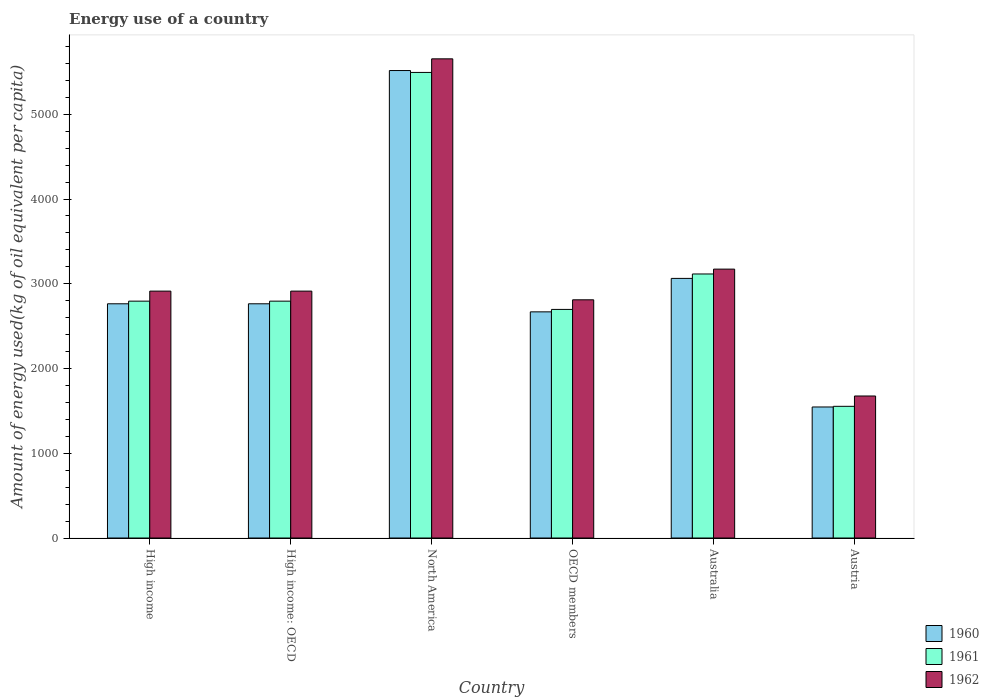How many groups of bars are there?
Your answer should be very brief. 6. Are the number of bars on each tick of the X-axis equal?
Your answer should be very brief. Yes. How many bars are there on the 2nd tick from the left?
Your response must be concise. 3. How many bars are there on the 5th tick from the right?
Keep it short and to the point. 3. In how many cases, is the number of bars for a given country not equal to the number of legend labels?
Offer a very short reply. 0. What is the amount of energy used in in 1960 in High income: OECD?
Your answer should be very brief. 2763.96. Across all countries, what is the maximum amount of energy used in in 1962?
Make the answer very short. 5654.54. Across all countries, what is the minimum amount of energy used in in 1961?
Ensure brevity in your answer.  1554.03. What is the total amount of energy used in in 1961 in the graph?
Provide a succinct answer. 1.85e+04. What is the difference between the amount of energy used in in 1962 in Australia and that in High income: OECD?
Keep it short and to the point. 259.55. What is the difference between the amount of energy used in in 1961 in Austria and the amount of energy used in in 1960 in Australia?
Offer a terse response. -1509.52. What is the average amount of energy used in in 1961 per country?
Offer a very short reply. 3075.28. What is the difference between the amount of energy used in of/in 1962 and amount of energy used in of/in 1960 in High income: OECD?
Give a very brief answer. 149.47. What is the ratio of the amount of energy used in in 1961 in Austria to that in High income?
Keep it short and to the point. 0.56. Is the difference between the amount of energy used in in 1962 in Australia and Austria greater than the difference between the amount of energy used in in 1960 in Australia and Austria?
Make the answer very short. No. What is the difference between the highest and the second highest amount of energy used in in 1961?
Your answer should be compact. -2378.3. What is the difference between the highest and the lowest amount of energy used in in 1962?
Provide a succinct answer. 3978.67. In how many countries, is the amount of energy used in in 1962 greater than the average amount of energy used in in 1962 taken over all countries?
Give a very brief answer. 1. Is the sum of the amount of energy used in in 1961 in Austria and High income: OECD greater than the maximum amount of energy used in in 1960 across all countries?
Your answer should be very brief. No. What does the 1st bar from the left in North America represents?
Your answer should be very brief. 1960. Is it the case that in every country, the sum of the amount of energy used in in 1962 and amount of energy used in in 1961 is greater than the amount of energy used in in 1960?
Keep it short and to the point. Yes. How many bars are there?
Ensure brevity in your answer.  18. How many countries are there in the graph?
Offer a terse response. 6. What is the difference between two consecutive major ticks on the Y-axis?
Offer a terse response. 1000. Are the values on the major ticks of Y-axis written in scientific E-notation?
Offer a terse response. No. How are the legend labels stacked?
Provide a short and direct response. Vertical. What is the title of the graph?
Your answer should be very brief. Energy use of a country. What is the label or title of the Y-axis?
Offer a terse response. Amount of energy used(kg of oil equivalent per capita). What is the Amount of energy used(kg of oil equivalent per capita) in 1960 in High income?
Your response must be concise. 2763.96. What is the Amount of energy used(kg of oil equivalent per capita) of 1961 in High income?
Give a very brief answer. 2795.14. What is the Amount of energy used(kg of oil equivalent per capita) in 1962 in High income?
Ensure brevity in your answer.  2913.43. What is the Amount of energy used(kg of oil equivalent per capita) of 1960 in High income: OECD?
Your answer should be compact. 2763.96. What is the Amount of energy used(kg of oil equivalent per capita) of 1961 in High income: OECD?
Ensure brevity in your answer.  2795.14. What is the Amount of energy used(kg of oil equivalent per capita) of 1962 in High income: OECD?
Your answer should be very brief. 2913.43. What is the Amount of energy used(kg of oil equivalent per capita) in 1960 in North America?
Your answer should be very brief. 5516.36. What is the Amount of energy used(kg of oil equivalent per capita) in 1961 in North America?
Provide a short and direct response. 5494.09. What is the Amount of energy used(kg of oil equivalent per capita) of 1962 in North America?
Make the answer very short. 5654.54. What is the Amount of energy used(kg of oil equivalent per capita) in 1960 in OECD members?
Give a very brief answer. 2668.69. What is the Amount of energy used(kg of oil equivalent per capita) of 1961 in OECD members?
Your response must be concise. 2697.51. What is the Amount of energy used(kg of oil equivalent per capita) in 1962 in OECD members?
Your answer should be very brief. 2810.85. What is the Amount of energy used(kg of oil equivalent per capita) in 1960 in Australia?
Offer a very short reply. 3063.55. What is the Amount of energy used(kg of oil equivalent per capita) of 1961 in Australia?
Offer a terse response. 3115.79. What is the Amount of energy used(kg of oil equivalent per capita) of 1962 in Australia?
Make the answer very short. 3172.97. What is the Amount of energy used(kg of oil equivalent per capita) of 1960 in Austria?
Provide a short and direct response. 1546.26. What is the Amount of energy used(kg of oil equivalent per capita) in 1961 in Austria?
Provide a short and direct response. 1554.03. What is the Amount of energy used(kg of oil equivalent per capita) of 1962 in Austria?
Offer a very short reply. 1675.87. Across all countries, what is the maximum Amount of energy used(kg of oil equivalent per capita) of 1960?
Offer a terse response. 5516.36. Across all countries, what is the maximum Amount of energy used(kg of oil equivalent per capita) in 1961?
Offer a very short reply. 5494.09. Across all countries, what is the maximum Amount of energy used(kg of oil equivalent per capita) of 1962?
Provide a succinct answer. 5654.54. Across all countries, what is the minimum Amount of energy used(kg of oil equivalent per capita) in 1960?
Ensure brevity in your answer.  1546.26. Across all countries, what is the minimum Amount of energy used(kg of oil equivalent per capita) in 1961?
Offer a terse response. 1554.03. Across all countries, what is the minimum Amount of energy used(kg of oil equivalent per capita) of 1962?
Your answer should be compact. 1675.87. What is the total Amount of energy used(kg of oil equivalent per capita) in 1960 in the graph?
Offer a very short reply. 1.83e+04. What is the total Amount of energy used(kg of oil equivalent per capita) in 1961 in the graph?
Offer a terse response. 1.85e+04. What is the total Amount of energy used(kg of oil equivalent per capita) in 1962 in the graph?
Your answer should be very brief. 1.91e+04. What is the difference between the Amount of energy used(kg of oil equivalent per capita) of 1960 in High income and that in High income: OECD?
Your response must be concise. 0. What is the difference between the Amount of energy used(kg of oil equivalent per capita) of 1962 in High income and that in High income: OECD?
Provide a short and direct response. 0. What is the difference between the Amount of energy used(kg of oil equivalent per capita) in 1960 in High income and that in North America?
Your response must be concise. -2752.4. What is the difference between the Amount of energy used(kg of oil equivalent per capita) of 1961 in High income and that in North America?
Offer a terse response. -2698.95. What is the difference between the Amount of energy used(kg of oil equivalent per capita) of 1962 in High income and that in North America?
Provide a succinct answer. -2741.12. What is the difference between the Amount of energy used(kg of oil equivalent per capita) of 1960 in High income and that in OECD members?
Offer a very short reply. 95.27. What is the difference between the Amount of energy used(kg of oil equivalent per capita) of 1961 in High income and that in OECD members?
Keep it short and to the point. 97.63. What is the difference between the Amount of energy used(kg of oil equivalent per capita) of 1962 in High income and that in OECD members?
Keep it short and to the point. 102.57. What is the difference between the Amount of energy used(kg of oil equivalent per capita) in 1960 in High income and that in Australia?
Keep it short and to the point. -299.59. What is the difference between the Amount of energy used(kg of oil equivalent per capita) in 1961 in High income and that in Australia?
Your answer should be compact. -320.65. What is the difference between the Amount of energy used(kg of oil equivalent per capita) in 1962 in High income and that in Australia?
Offer a terse response. -259.55. What is the difference between the Amount of energy used(kg of oil equivalent per capita) in 1960 in High income and that in Austria?
Your response must be concise. 1217.7. What is the difference between the Amount of energy used(kg of oil equivalent per capita) in 1961 in High income and that in Austria?
Your response must be concise. 1241.11. What is the difference between the Amount of energy used(kg of oil equivalent per capita) in 1962 in High income and that in Austria?
Make the answer very short. 1237.55. What is the difference between the Amount of energy used(kg of oil equivalent per capita) of 1960 in High income: OECD and that in North America?
Your response must be concise. -2752.4. What is the difference between the Amount of energy used(kg of oil equivalent per capita) in 1961 in High income: OECD and that in North America?
Provide a succinct answer. -2698.95. What is the difference between the Amount of energy used(kg of oil equivalent per capita) of 1962 in High income: OECD and that in North America?
Offer a terse response. -2741.12. What is the difference between the Amount of energy used(kg of oil equivalent per capita) in 1960 in High income: OECD and that in OECD members?
Provide a succinct answer. 95.27. What is the difference between the Amount of energy used(kg of oil equivalent per capita) of 1961 in High income: OECD and that in OECD members?
Offer a very short reply. 97.63. What is the difference between the Amount of energy used(kg of oil equivalent per capita) in 1962 in High income: OECD and that in OECD members?
Provide a short and direct response. 102.57. What is the difference between the Amount of energy used(kg of oil equivalent per capita) in 1960 in High income: OECD and that in Australia?
Ensure brevity in your answer.  -299.59. What is the difference between the Amount of energy used(kg of oil equivalent per capita) of 1961 in High income: OECD and that in Australia?
Offer a very short reply. -320.65. What is the difference between the Amount of energy used(kg of oil equivalent per capita) in 1962 in High income: OECD and that in Australia?
Provide a succinct answer. -259.55. What is the difference between the Amount of energy used(kg of oil equivalent per capita) of 1960 in High income: OECD and that in Austria?
Give a very brief answer. 1217.7. What is the difference between the Amount of energy used(kg of oil equivalent per capita) of 1961 in High income: OECD and that in Austria?
Your answer should be very brief. 1241.11. What is the difference between the Amount of energy used(kg of oil equivalent per capita) of 1962 in High income: OECD and that in Austria?
Keep it short and to the point. 1237.55. What is the difference between the Amount of energy used(kg of oil equivalent per capita) in 1960 in North America and that in OECD members?
Give a very brief answer. 2847.66. What is the difference between the Amount of energy used(kg of oil equivalent per capita) in 1961 in North America and that in OECD members?
Offer a terse response. 2796.57. What is the difference between the Amount of energy used(kg of oil equivalent per capita) of 1962 in North America and that in OECD members?
Ensure brevity in your answer.  2843.69. What is the difference between the Amount of energy used(kg of oil equivalent per capita) of 1960 in North America and that in Australia?
Keep it short and to the point. 2452.8. What is the difference between the Amount of energy used(kg of oil equivalent per capita) of 1961 in North America and that in Australia?
Provide a short and direct response. 2378.3. What is the difference between the Amount of energy used(kg of oil equivalent per capita) of 1962 in North America and that in Australia?
Your answer should be very brief. 2481.57. What is the difference between the Amount of energy used(kg of oil equivalent per capita) of 1960 in North America and that in Austria?
Provide a short and direct response. 3970.09. What is the difference between the Amount of energy used(kg of oil equivalent per capita) in 1961 in North America and that in Austria?
Keep it short and to the point. 3940.05. What is the difference between the Amount of energy used(kg of oil equivalent per capita) in 1962 in North America and that in Austria?
Give a very brief answer. 3978.67. What is the difference between the Amount of energy used(kg of oil equivalent per capita) in 1960 in OECD members and that in Australia?
Provide a succinct answer. -394.86. What is the difference between the Amount of energy used(kg of oil equivalent per capita) of 1961 in OECD members and that in Australia?
Ensure brevity in your answer.  -418.27. What is the difference between the Amount of energy used(kg of oil equivalent per capita) in 1962 in OECD members and that in Australia?
Provide a short and direct response. -362.12. What is the difference between the Amount of energy used(kg of oil equivalent per capita) in 1960 in OECD members and that in Austria?
Offer a very short reply. 1122.43. What is the difference between the Amount of energy used(kg of oil equivalent per capita) of 1961 in OECD members and that in Austria?
Your answer should be very brief. 1143.48. What is the difference between the Amount of energy used(kg of oil equivalent per capita) of 1962 in OECD members and that in Austria?
Your response must be concise. 1134.98. What is the difference between the Amount of energy used(kg of oil equivalent per capita) of 1960 in Australia and that in Austria?
Offer a very short reply. 1517.29. What is the difference between the Amount of energy used(kg of oil equivalent per capita) of 1961 in Australia and that in Austria?
Provide a short and direct response. 1561.75. What is the difference between the Amount of energy used(kg of oil equivalent per capita) of 1962 in Australia and that in Austria?
Provide a succinct answer. 1497.1. What is the difference between the Amount of energy used(kg of oil equivalent per capita) in 1960 in High income and the Amount of energy used(kg of oil equivalent per capita) in 1961 in High income: OECD?
Offer a terse response. -31.18. What is the difference between the Amount of energy used(kg of oil equivalent per capita) in 1960 in High income and the Amount of energy used(kg of oil equivalent per capita) in 1962 in High income: OECD?
Your response must be concise. -149.47. What is the difference between the Amount of energy used(kg of oil equivalent per capita) in 1961 in High income and the Amount of energy used(kg of oil equivalent per capita) in 1962 in High income: OECD?
Keep it short and to the point. -118.28. What is the difference between the Amount of energy used(kg of oil equivalent per capita) of 1960 in High income and the Amount of energy used(kg of oil equivalent per capita) of 1961 in North America?
Make the answer very short. -2730.13. What is the difference between the Amount of energy used(kg of oil equivalent per capita) of 1960 in High income and the Amount of energy used(kg of oil equivalent per capita) of 1962 in North America?
Keep it short and to the point. -2890.59. What is the difference between the Amount of energy used(kg of oil equivalent per capita) of 1961 in High income and the Amount of energy used(kg of oil equivalent per capita) of 1962 in North America?
Give a very brief answer. -2859.4. What is the difference between the Amount of energy used(kg of oil equivalent per capita) in 1960 in High income and the Amount of energy used(kg of oil equivalent per capita) in 1961 in OECD members?
Your answer should be very brief. 66.45. What is the difference between the Amount of energy used(kg of oil equivalent per capita) in 1960 in High income and the Amount of energy used(kg of oil equivalent per capita) in 1962 in OECD members?
Your answer should be compact. -46.89. What is the difference between the Amount of energy used(kg of oil equivalent per capita) of 1961 in High income and the Amount of energy used(kg of oil equivalent per capita) of 1962 in OECD members?
Your response must be concise. -15.71. What is the difference between the Amount of energy used(kg of oil equivalent per capita) of 1960 in High income and the Amount of energy used(kg of oil equivalent per capita) of 1961 in Australia?
Provide a succinct answer. -351.83. What is the difference between the Amount of energy used(kg of oil equivalent per capita) in 1960 in High income and the Amount of energy used(kg of oil equivalent per capita) in 1962 in Australia?
Provide a short and direct response. -409.02. What is the difference between the Amount of energy used(kg of oil equivalent per capita) in 1961 in High income and the Amount of energy used(kg of oil equivalent per capita) in 1962 in Australia?
Offer a very short reply. -377.83. What is the difference between the Amount of energy used(kg of oil equivalent per capita) in 1960 in High income and the Amount of energy used(kg of oil equivalent per capita) in 1961 in Austria?
Your answer should be compact. 1209.92. What is the difference between the Amount of energy used(kg of oil equivalent per capita) of 1960 in High income and the Amount of energy used(kg of oil equivalent per capita) of 1962 in Austria?
Offer a terse response. 1088.09. What is the difference between the Amount of energy used(kg of oil equivalent per capita) in 1961 in High income and the Amount of energy used(kg of oil equivalent per capita) in 1962 in Austria?
Ensure brevity in your answer.  1119.27. What is the difference between the Amount of energy used(kg of oil equivalent per capita) of 1960 in High income: OECD and the Amount of energy used(kg of oil equivalent per capita) of 1961 in North America?
Your response must be concise. -2730.13. What is the difference between the Amount of energy used(kg of oil equivalent per capita) in 1960 in High income: OECD and the Amount of energy used(kg of oil equivalent per capita) in 1962 in North America?
Provide a succinct answer. -2890.59. What is the difference between the Amount of energy used(kg of oil equivalent per capita) in 1961 in High income: OECD and the Amount of energy used(kg of oil equivalent per capita) in 1962 in North America?
Give a very brief answer. -2859.4. What is the difference between the Amount of energy used(kg of oil equivalent per capita) in 1960 in High income: OECD and the Amount of energy used(kg of oil equivalent per capita) in 1961 in OECD members?
Give a very brief answer. 66.45. What is the difference between the Amount of energy used(kg of oil equivalent per capita) in 1960 in High income: OECD and the Amount of energy used(kg of oil equivalent per capita) in 1962 in OECD members?
Ensure brevity in your answer.  -46.89. What is the difference between the Amount of energy used(kg of oil equivalent per capita) in 1961 in High income: OECD and the Amount of energy used(kg of oil equivalent per capita) in 1962 in OECD members?
Your answer should be compact. -15.71. What is the difference between the Amount of energy used(kg of oil equivalent per capita) of 1960 in High income: OECD and the Amount of energy used(kg of oil equivalent per capita) of 1961 in Australia?
Your answer should be compact. -351.83. What is the difference between the Amount of energy used(kg of oil equivalent per capita) in 1960 in High income: OECD and the Amount of energy used(kg of oil equivalent per capita) in 1962 in Australia?
Offer a terse response. -409.02. What is the difference between the Amount of energy used(kg of oil equivalent per capita) in 1961 in High income: OECD and the Amount of energy used(kg of oil equivalent per capita) in 1962 in Australia?
Offer a terse response. -377.83. What is the difference between the Amount of energy used(kg of oil equivalent per capita) of 1960 in High income: OECD and the Amount of energy used(kg of oil equivalent per capita) of 1961 in Austria?
Offer a terse response. 1209.92. What is the difference between the Amount of energy used(kg of oil equivalent per capita) of 1960 in High income: OECD and the Amount of energy used(kg of oil equivalent per capita) of 1962 in Austria?
Provide a short and direct response. 1088.09. What is the difference between the Amount of energy used(kg of oil equivalent per capita) of 1961 in High income: OECD and the Amount of energy used(kg of oil equivalent per capita) of 1962 in Austria?
Your answer should be very brief. 1119.27. What is the difference between the Amount of energy used(kg of oil equivalent per capita) of 1960 in North America and the Amount of energy used(kg of oil equivalent per capita) of 1961 in OECD members?
Give a very brief answer. 2818.84. What is the difference between the Amount of energy used(kg of oil equivalent per capita) of 1960 in North America and the Amount of energy used(kg of oil equivalent per capita) of 1962 in OECD members?
Offer a terse response. 2705.5. What is the difference between the Amount of energy used(kg of oil equivalent per capita) in 1961 in North America and the Amount of energy used(kg of oil equivalent per capita) in 1962 in OECD members?
Your answer should be very brief. 2683.23. What is the difference between the Amount of energy used(kg of oil equivalent per capita) of 1960 in North America and the Amount of energy used(kg of oil equivalent per capita) of 1961 in Australia?
Offer a very short reply. 2400.57. What is the difference between the Amount of energy used(kg of oil equivalent per capita) in 1960 in North America and the Amount of energy used(kg of oil equivalent per capita) in 1962 in Australia?
Give a very brief answer. 2343.38. What is the difference between the Amount of energy used(kg of oil equivalent per capita) of 1961 in North America and the Amount of energy used(kg of oil equivalent per capita) of 1962 in Australia?
Keep it short and to the point. 2321.11. What is the difference between the Amount of energy used(kg of oil equivalent per capita) in 1960 in North America and the Amount of energy used(kg of oil equivalent per capita) in 1961 in Austria?
Your answer should be compact. 3962.32. What is the difference between the Amount of energy used(kg of oil equivalent per capita) in 1960 in North America and the Amount of energy used(kg of oil equivalent per capita) in 1962 in Austria?
Your answer should be very brief. 3840.48. What is the difference between the Amount of energy used(kg of oil equivalent per capita) of 1961 in North America and the Amount of energy used(kg of oil equivalent per capita) of 1962 in Austria?
Offer a very short reply. 3818.21. What is the difference between the Amount of energy used(kg of oil equivalent per capita) of 1960 in OECD members and the Amount of energy used(kg of oil equivalent per capita) of 1961 in Australia?
Give a very brief answer. -447.09. What is the difference between the Amount of energy used(kg of oil equivalent per capita) in 1960 in OECD members and the Amount of energy used(kg of oil equivalent per capita) in 1962 in Australia?
Ensure brevity in your answer.  -504.28. What is the difference between the Amount of energy used(kg of oil equivalent per capita) of 1961 in OECD members and the Amount of energy used(kg of oil equivalent per capita) of 1962 in Australia?
Provide a succinct answer. -475.46. What is the difference between the Amount of energy used(kg of oil equivalent per capita) of 1960 in OECD members and the Amount of energy used(kg of oil equivalent per capita) of 1961 in Austria?
Your answer should be compact. 1114.66. What is the difference between the Amount of energy used(kg of oil equivalent per capita) in 1960 in OECD members and the Amount of energy used(kg of oil equivalent per capita) in 1962 in Austria?
Your answer should be compact. 992.82. What is the difference between the Amount of energy used(kg of oil equivalent per capita) of 1961 in OECD members and the Amount of energy used(kg of oil equivalent per capita) of 1962 in Austria?
Keep it short and to the point. 1021.64. What is the difference between the Amount of energy used(kg of oil equivalent per capita) in 1960 in Australia and the Amount of energy used(kg of oil equivalent per capita) in 1961 in Austria?
Keep it short and to the point. 1509.52. What is the difference between the Amount of energy used(kg of oil equivalent per capita) of 1960 in Australia and the Amount of energy used(kg of oil equivalent per capita) of 1962 in Austria?
Offer a terse response. 1387.68. What is the difference between the Amount of energy used(kg of oil equivalent per capita) in 1961 in Australia and the Amount of energy used(kg of oil equivalent per capita) in 1962 in Austria?
Provide a succinct answer. 1439.91. What is the average Amount of energy used(kg of oil equivalent per capita) of 1960 per country?
Ensure brevity in your answer.  3053.8. What is the average Amount of energy used(kg of oil equivalent per capita) in 1961 per country?
Your answer should be compact. 3075.28. What is the average Amount of energy used(kg of oil equivalent per capita) in 1962 per country?
Make the answer very short. 3190.18. What is the difference between the Amount of energy used(kg of oil equivalent per capita) of 1960 and Amount of energy used(kg of oil equivalent per capita) of 1961 in High income?
Offer a terse response. -31.18. What is the difference between the Amount of energy used(kg of oil equivalent per capita) of 1960 and Amount of energy used(kg of oil equivalent per capita) of 1962 in High income?
Make the answer very short. -149.47. What is the difference between the Amount of energy used(kg of oil equivalent per capita) of 1961 and Amount of energy used(kg of oil equivalent per capita) of 1962 in High income?
Ensure brevity in your answer.  -118.28. What is the difference between the Amount of energy used(kg of oil equivalent per capita) in 1960 and Amount of energy used(kg of oil equivalent per capita) in 1961 in High income: OECD?
Your answer should be compact. -31.18. What is the difference between the Amount of energy used(kg of oil equivalent per capita) of 1960 and Amount of energy used(kg of oil equivalent per capita) of 1962 in High income: OECD?
Provide a succinct answer. -149.47. What is the difference between the Amount of energy used(kg of oil equivalent per capita) in 1961 and Amount of energy used(kg of oil equivalent per capita) in 1962 in High income: OECD?
Provide a short and direct response. -118.28. What is the difference between the Amount of energy used(kg of oil equivalent per capita) in 1960 and Amount of energy used(kg of oil equivalent per capita) in 1961 in North America?
Keep it short and to the point. 22.27. What is the difference between the Amount of energy used(kg of oil equivalent per capita) in 1960 and Amount of energy used(kg of oil equivalent per capita) in 1962 in North America?
Your response must be concise. -138.19. What is the difference between the Amount of energy used(kg of oil equivalent per capita) of 1961 and Amount of energy used(kg of oil equivalent per capita) of 1962 in North America?
Provide a succinct answer. -160.46. What is the difference between the Amount of energy used(kg of oil equivalent per capita) in 1960 and Amount of energy used(kg of oil equivalent per capita) in 1961 in OECD members?
Offer a very short reply. -28.82. What is the difference between the Amount of energy used(kg of oil equivalent per capita) in 1960 and Amount of energy used(kg of oil equivalent per capita) in 1962 in OECD members?
Give a very brief answer. -142.16. What is the difference between the Amount of energy used(kg of oil equivalent per capita) of 1961 and Amount of energy used(kg of oil equivalent per capita) of 1962 in OECD members?
Make the answer very short. -113.34. What is the difference between the Amount of energy used(kg of oil equivalent per capita) of 1960 and Amount of energy used(kg of oil equivalent per capita) of 1961 in Australia?
Make the answer very short. -52.23. What is the difference between the Amount of energy used(kg of oil equivalent per capita) of 1960 and Amount of energy used(kg of oil equivalent per capita) of 1962 in Australia?
Offer a terse response. -109.42. What is the difference between the Amount of energy used(kg of oil equivalent per capita) of 1961 and Amount of energy used(kg of oil equivalent per capita) of 1962 in Australia?
Provide a succinct answer. -57.19. What is the difference between the Amount of energy used(kg of oil equivalent per capita) in 1960 and Amount of energy used(kg of oil equivalent per capita) in 1961 in Austria?
Offer a very short reply. -7.77. What is the difference between the Amount of energy used(kg of oil equivalent per capita) of 1960 and Amount of energy used(kg of oil equivalent per capita) of 1962 in Austria?
Offer a terse response. -129.61. What is the difference between the Amount of energy used(kg of oil equivalent per capita) of 1961 and Amount of energy used(kg of oil equivalent per capita) of 1962 in Austria?
Offer a terse response. -121.84. What is the ratio of the Amount of energy used(kg of oil equivalent per capita) in 1960 in High income to that in High income: OECD?
Offer a very short reply. 1. What is the ratio of the Amount of energy used(kg of oil equivalent per capita) of 1960 in High income to that in North America?
Offer a terse response. 0.5. What is the ratio of the Amount of energy used(kg of oil equivalent per capita) of 1961 in High income to that in North America?
Your response must be concise. 0.51. What is the ratio of the Amount of energy used(kg of oil equivalent per capita) of 1962 in High income to that in North America?
Offer a terse response. 0.52. What is the ratio of the Amount of energy used(kg of oil equivalent per capita) of 1960 in High income to that in OECD members?
Offer a very short reply. 1.04. What is the ratio of the Amount of energy used(kg of oil equivalent per capita) in 1961 in High income to that in OECD members?
Your answer should be very brief. 1.04. What is the ratio of the Amount of energy used(kg of oil equivalent per capita) in 1962 in High income to that in OECD members?
Your response must be concise. 1.04. What is the ratio of the Amount of energy used(kg of oil equivalent per capita) in 1960 in High income to that in Australia?
Provide a succinct answer. 0.9. What is the ratio of the Amount of energy used(kg of oil equivalent per capita) in 1961 in High income to that in Australia?
Ensure brevity in your answer.  0.9. What is the ratio of the Amount of energy used(kg of oil equivalent per capita) in 1962 in High income to that in Australia?
Offer a terse response. 0.92. What is the ratio of the Amount of energy used(kg of oil equivalent per capita) in 1960 in High income to that in Austria?
Make the answer very short. 1.79. What is the ratio of the Amount of energy used(kg of oil equivalent per capita) of 1961 in High income to that in Austria?
Your response must be concise. 1.8. What is the ratio of the Amount of energy used(kg of oil equivalent per capita) of 1962 in High income to that in Austria?
Give a very brief answer. 1.74. What is the ratio of the Amount of energy used(kg of oil equivalent per capita) of 1960 in High income: OECD to that in North America?
Make the answer very short. 0.5. What is the ratio of the Amount of energy used(kg of oil equivalent per capita) of 1961 in High income: OECD to that in North America?
Your answer should be compact. 0.51. What is the ratio of the Amount of energy used(kg of oil equivalent per capita) of 1962 in High income: OECD to that in North America?
Provide a succinct answer. 0.52. What is the ratio of the Amount of energy used(kg of oil equivalent per capita) in 1960 in High income: OECD to that in OECD members?
Your answer should be compact. 1.04. What is the ratio of the Amount of energy used(kg of oil equivalent per capita) of 1961 in High income: OECD to that in OECD members?
Your answer should be very brief. 1.04. What is the ratio of the Amount of energy used(kg of oil equivalent per capita) in 1962 in High income: OECD to that in OECD members?
Your answer should be very brief. 1.04. What is the ratio of the Amount of energy used(kg of oil equivalent per capita) in 1960 in High income: OECD to that in Australia?
Offer a very short reply. 0.9. What is the ratio of the Amount of energy used(kg of oil equivalent per capita) of 1961 in High income: OECD to that in Australia?
Ensure brevity in your answer.  0.9. What is the ratio of the Amount of energy used(kg of oil equivalent per capita) of 1962 in High income: OECD to that in Australia?
Ensure brevity in your answer.  0.92. What is the ratio of the Amount of energy used(kg of oil equivalent per capita) of 1960 in High income: OECD to that in Austria?
Offer a terse response. 1.79. What is the ratio of the Amount of energy used(kg of oil equivalent per capita) of 1961 in High income: OECD to that in Austria?
Your response must be concise. 1.8. What is the ratio of the Amount of energy used(kg of oil equivalent per capita) in 1962 in High income: OECD to that in Austria?
Your answer should be very brief. 1.74. What is the ratio of the Amount of energy used(kg of oil equivalent per capita) in 1960 in North America to that in OECD members?
Your response must be concise. 2.07. What is the ratio of the Amount of energy used(kg of oil equivalent per capita) in 1961 in North America to that in OECD members?
Provide a succinct answer. 2.04. What is the ratio of the Amount of energy used(kg of oil equivalent per capita) in 1962 in North America to that in OECD members?
Offer a very short reply. 2.01. What is the ratio of the Amount of energy used(kg of oil equivalent per capita) in 1960 in North America to that in Australia?
Offer a terse response. 1.8. What is the ratio of the Amount of energy used(kg of oil equivalent per capita) of 1961 in North America to that in Australia?
Provide a short and direct response. 1.76. What is the ratio of the Amount of energy used(kg of oil equivalent per capita) in 1962 in North America to that in Australia?
Your answer should be very brief. 1.78. What is the ratio of the Amount of energy used(kg of oil equivalent per capita) in 1960 in North America to that in Austria?
Provide a short and direct response. 3.57. What is the ratio of the Amount of energy used(kg of oil equivalent per capita) in 1961 in North America to that in Austria?
Give a very brief answer. 3.54. What is the ratio of the Amount of energy used(kg of oil equivalent per capita) of 1962 in North America to that in Austria?
Keep it short and to the point. 3.37. What is the ratio of the Amount of energy used(kg of oil equivalent per capita) of 1960 in OECD members to that in Australia?
Offer a terse response. 0.87. What is the ratio of the Amount of energy used(kg of oil equivalent per capita) of 1961 in OECD members to that in Australia?
Your answer should be compact. 0.87. What is the ratio of the Amount of energy used(kg of oil equivalent per capita) of 1962 in OECD members to that in Australia?
Offer a terse response. 0.89. What is the ratio of the Amount of energy used(kg of oil equivalent per capita) of 1960 in OECD members to that in Austria?
Ensure brevity in your answer.  1.73. What is the ratio of the Amount of energy used(kg of oil equivalent per capita) in 1961 in OECD members to that in Austria?
Offer a very short reply. 1.74. What is the ratio of the Amount of energy used(kg of oil equivalent per capita) of 1962 in OECD members to that in Austria?
Make the answer very short. 1.68. What is the ratio of the Amount of energy used(kg of oil equivalent per capita) in 1960 in Australia to that in Austria?
Your response must be concise. 1.98. What is the ratio of the Amount of energy used(kg of oil equivalent per capita) in 1961 in Australia to that in Austria?
Keep it short and to the point. 2. What is the ratio of the Amount of energy used(kg of oil equivalent per capita) in 1962 in Australia to that in Austria?
Offer a terse response. 1.89. What is the difference between the highest and the second highest Amount of energy used(kg of oil equivalent per capita) in 1960?
Provide a short and direct response. 2452.8. What is the difference between the highest and the second highest Amount of energy used(kg of oil equivalent per capita) of 1961?
Your answer should be compact. 2378.3. What is the difference between the highest and the second highest Amount of energy used(kg of oil equivalent per capita) in 1962?
Offer a very short reply. 2481.57. What is the difference between the highest and the lowest Amount of energy used(kg of oil equivalent per capita) of 1960?
Your answer should be compact. 3970.09. What is the difference between the highest and the lowest Amount of energy used(kg of oil equivalent per capita) of 1961?
Make the answer very short. 3940.05. What is the difference between the highest and the lowest Amount of energy used(kg of oil equivalent per capita) in 1962?
Give a very brief answer. 3978.67. 